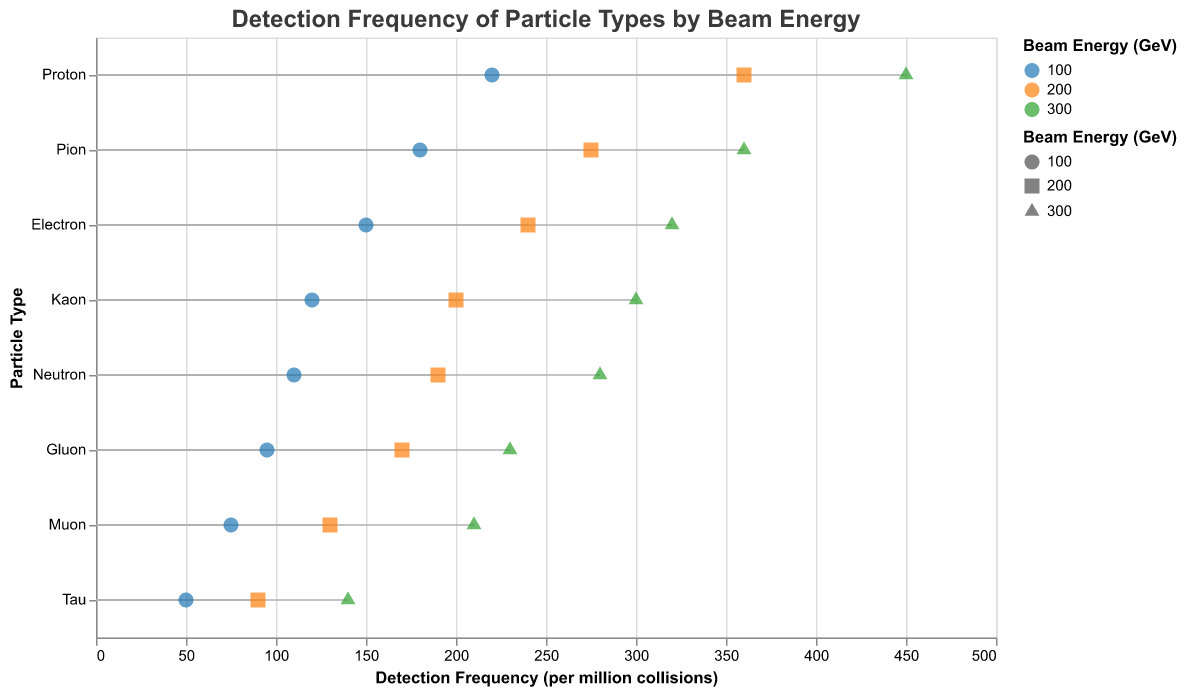What is the title of the figure? The title of the figure is typically displayed at the top and gives an overview of what the figure represents. In this case, it states "Detection Frequency of Particle Types by Beam Energy".
Answer: Detection Frequency of Particle Types by Beam Energy What is the detection frequency of muons at 300 GeV? To find this, locate the data point for muons with a beam energy of 300 GeV, then read the detection frequency value from the x-axis scale.
Answer: 210 per million collisions Which particle has the highest detection frequency at 100 GeV? To determine this, look at the points corresponding to 100 GeV and identify which one is the furthest to the right (indicating the highest value on the x-axis).
Answer: Proton What is the range of detection frequencies for electrons across all energy levels? Examine the positions of electron points at 100 GeV, 200 GeV, and 300 GeV, noting the lowest and highest x-axis values. Subtract the smallest value from the largest.
Answer: 170 per million collisions Which particle type has the smallest increase in detection frequency between 100 GeV and 300 GeV? Calculate the difference in detection frequency for each particle type between 100 GeV and 300 GeV, then identify the smallest difference. For example, for Tau, calculate 140 - 50 = 90 per million collisions. Repeat for the other particles.
Answer: Tau How does the detection frequency of protons at 200 GeV compare to neutrons at the same energy level? Identify the points for protons and neutrons at 200 GeV and compare their x-axis values. Protons at 200 GeV have a frequency of 360, while neutrons have 190.
Answer: Protons are higher Which beam energy level shows the most consistent detection frequency across all particle types? Analyzing the spread of detection frequencies (range) across different particle types for each beam energy, note the variability. For example, at 100 GeV, the range is from 50 to 220, while at 200 GeV, the range is from 90 to 360.
Answer: 300 GeV What is the detection frequency of the particle type with the lowest frequency at 300 GeV? Find the point with the smallest value on the x-axis at 300 GeV. In this case, Tau has the lowest frequency among the particles at 300 GeV with a value of 140.
Answer: 140 per million collisions What is the average detection frequency of pions across all beam energy levels? Add the detection frequencies of pions at 100 GeV, 200 GeV, and 300 GeV, then divide by the number of data points (3): (180 + 275 + 360) / 3 = 271.67 per million collisions.
Answer: 271.67 per million collisions Which particle type has the most significant increase in detection frequency when the beam energy is increased from 100 GeV to 200 GeV? For each particle type, subtract the detection frequency at 100 GeV from the frequency at 200 GeV. Identify the largest difference. For example, for Pions, it is 275 - 180 = 95 per million collisions. Repeat for the others.
Answer: Pion 